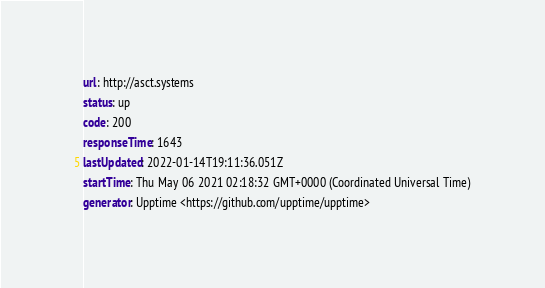Convert code to text. <code><loc_0><loc_0><loc_500><loc_500><_YAML_>url: http://asct.systems
status: up
code: 200
responseTime: 1643
lastUpdated: 2022-01-14T19:11:36.051Z
startTime: Thu May 06 2021 02:18:32 GMT+0000 (Coordinated Universal Time)
generator: Upptime <https://github.com/upptime/upptime>
</code> 